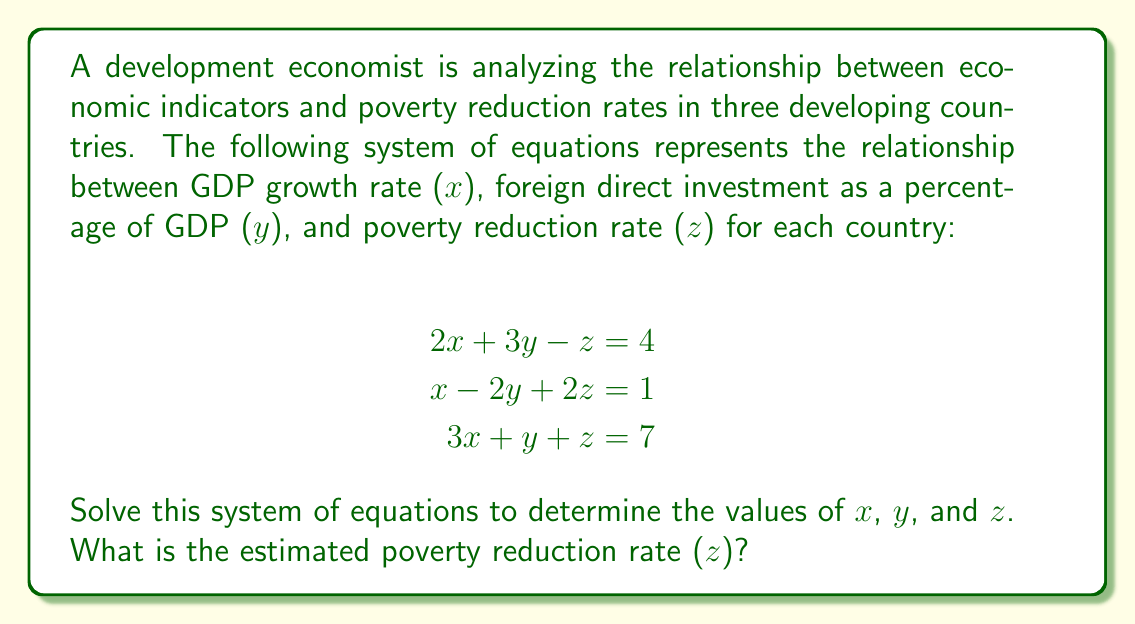Can you solve this math problem? To solve this system of equations, we'll use the elimination method:

1) Multiply the first equation by 2 and the second equation by 3:
   $$\begin{align}
   4x + 6y - 2z &= 8 \\
   3x - 6y + 6z &= 3
   \end{align}$$

2) Add these equations to eliminate y:
   $$7x + 4z = 11$$

3) Multiply the original first equation by 3 and the third equation by -1:
   $$\begin{align}
   6x + 9y - 3z &= 12 \\
   -3x - y - z &= -7
   \end{align}$$

4) Add these equations to eliminate x:
   $$8y - 4z = 5$$

5) Now we have two equations with two unknowns:
   $$\begin{align}
   7x + 4z &= 11 \\
   8y - 4z &= 5
   \end{align}$$

6) From the second equation: $y = \frac{5 + 4z}{8}$

7) Substitute this into the original second equation:
   $$x - 2(\frac{5 + 4z}{8}) + 2z = 1$$
   $$8x - 10 - 8z + 16z = 8$$
   $$8x + 8z = 18$$
   $$x + z = \frac{9}{4}$$

8) Substitute this into the equation from step 5:
   $$7(\frac{9}{4} - z) + 4z = 11$$
   $$\frac{63}{4} - 7z + 4z = 11$$
   $$\frac{63}{4} - 3z = 11$$
   $$-3z = 11 - \frac{63}{4} = -\frac{19}{4}$$
   $$z = \frac{19}{12}$$

9) Now we can find x and y:
   $$x = \frac{9}{4} - z = \frac{9}{4} - \frac{19}{12} = \frac{8}{12} = \frac{2}{3}$$
   $$y = \frac{5 + 4z}{8} = \frac{5 + 4(\frac{19}{12})}{8} = \frac{5 + \frac{19}{3}}{8} = \frac{34}{24} = \frac{17}{12}$$

Therefore, x = 2/3, y = 17/12, and z = 19/12.
Answer: $z = \frac{19}{12}$ or approximately 1.58 